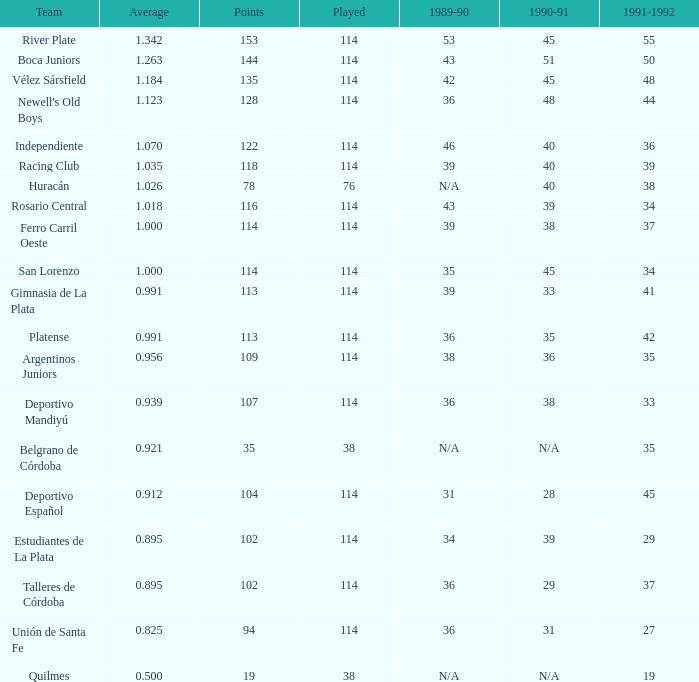What is the average for a 1989-90 season consisting of 36, a team from talleres de córdoba, and a performance below 114? 0.0. 